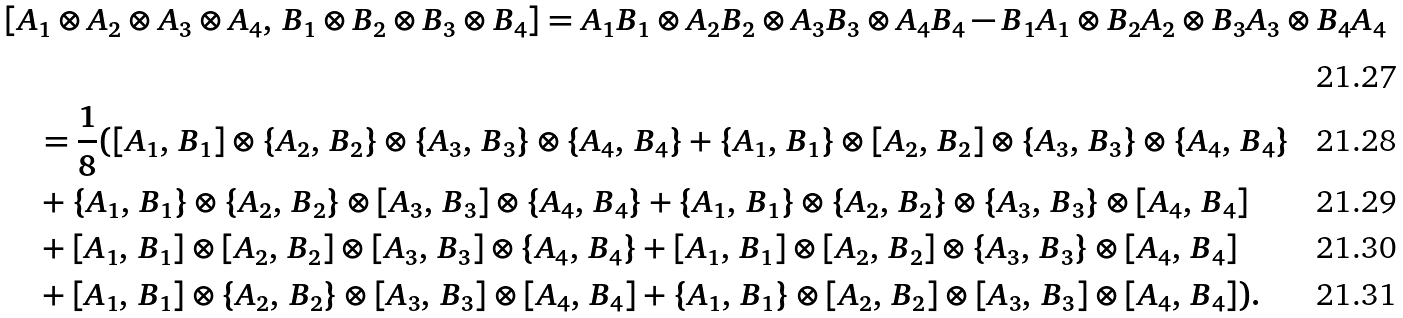<formula> <loc_0><loc_0><loc_500><loc_500>& [ A _ { 1 } \otimes A _ { 2 } \otimes A _ { 3 } \otimes A _ { 4 } , \, B _ { 1 } \otimes B _ { 2 } \otimes B _ { 3 } \otimes B _ { 4 } ] = A _ { 1 } B _ { 1 } \otimes A _ { 2 } B _ { 2 } \otimes A _ { 3 } B _ { 3 } \otimes A _ { 4 } B _ { 4 } - B _ { 1 } A _ { 1 } \otimes B _ { 2 } A _ { 2 } \otimes B _ { 3 } A _ { 3 } \otimes B _ { 4 } A _ { 4 } \\ & \quad = \frac { 1 } { 8 } ( [ A _ { 1 } , \, B _ { 1 } ] \otimes \{ A _ { 2 } , \, B _ { 2 } \} \otimes \{ A _ { 3 } , \, B _ { 3 } \} \otimes \{ A _ { 4 } , \, B _ { 4 } \} + \{ A _ { 1 } , \, B _ { 1 } \} \otimes [ A _ { 2 } , \, B _ { 2 } ] \otimes \{ A _ { 3 } , \, B _ { 3 } \} \otimes \{ A _ { 4 } , \, B _ { 4 } \} \\ & \quad + \{ A _ { 1 } , \, B _ { 1 } \} \otimes \{ A _ { 2 } , \, B _ { 2 } \} \otimes [ A _ { 3 } , \, B _ { 3 } ] \otimes \{ A _ { 4 } , \, B _ { 4 } \} + \{ A _ { 1 } , \, B _ { 1 } \} \otimes \{ A _ { 2 } , \, B _ { 2 } \} \otimes \{ A _ { 3 } , \, B _ { 3 } \} \otimes [ A _ { 4 } , \, B _ { 4 } ] \\ & \quad + [ A _ { 1 } , \, B _ { 1 } ] \otimes [ A _ { 2 } , \, B _ { 2 } ] \otimes [ A _ { 3 } , \, B _ { 3 } ] \otimes \{ A _ { 4 } , \, B _ { 4 } \} + [ A _ { 1 } , \, B _ { 1 } ] \otimes [ A _ { 2 } , \, B _ { 2 } ] \otimes \{ A _ { 3 } , \, B _ { 3 } \} \otimes [ A _ { 4 } , \, B _ { 4 } ] \\ & \quad + [ A _ { 1 } , \, B _ { 1 } ] \otimes \{ A _ { 2 } , \, B _ { 2 } \} \otimes [ A _ { 3 } , \, B _ { 3 } ] \otimes [ A _ { 4 } , \, B _ { 4 } ] + \{ A _ { 1 } , \, B _ { 1 } \} \otimes [ A _ { 2 } , \, B _ { 2 } ] \otimes [ A _ { 3 } , \, B _ { 3 } ] \otimes [ A _ { 4 } , \, B _ { 4 } ] ) .</formula> 